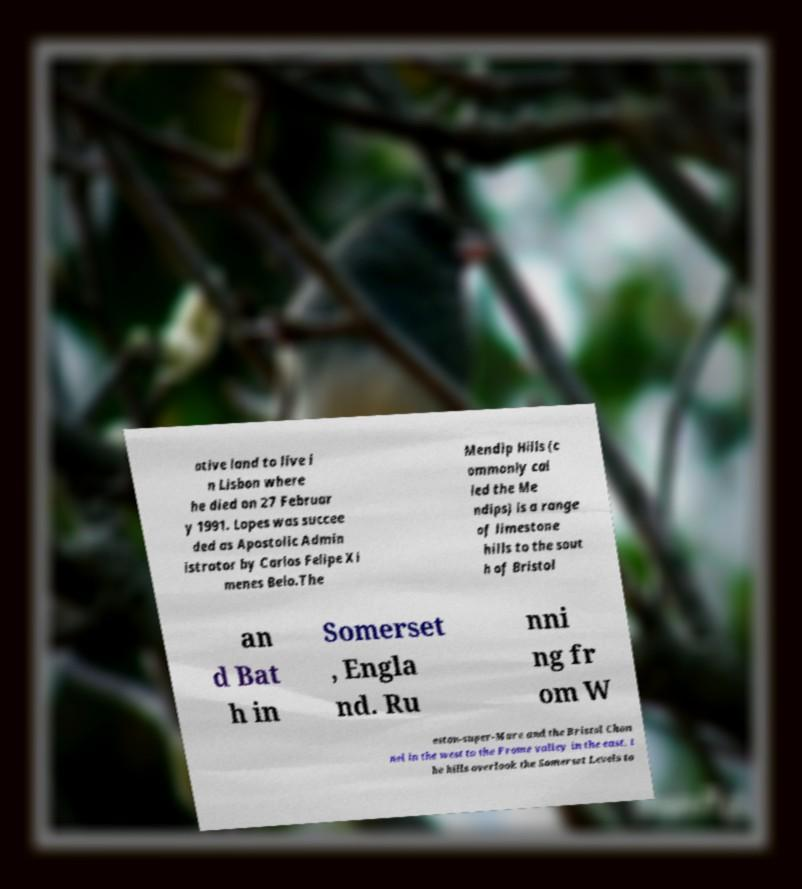Please identify and transcribe the text found in this image. ative land to live i n Lisbon where he died on 27 Februar y 1991. Lopes was succee ded as Apostolic Admin istrator by Carlos Felipe Xi menes Belo.The Mendip Hills (c ommonly cal led the Me ndips) is a range of limestone hills to the sout h of Bristol an d Bat h in Somerset , Engla nd. Ru nni ng fr om W eston-super-Mare and the Bristol Chan nel in the west to the Frome valley in the east, t he hills overlook the Somerset Levels to 